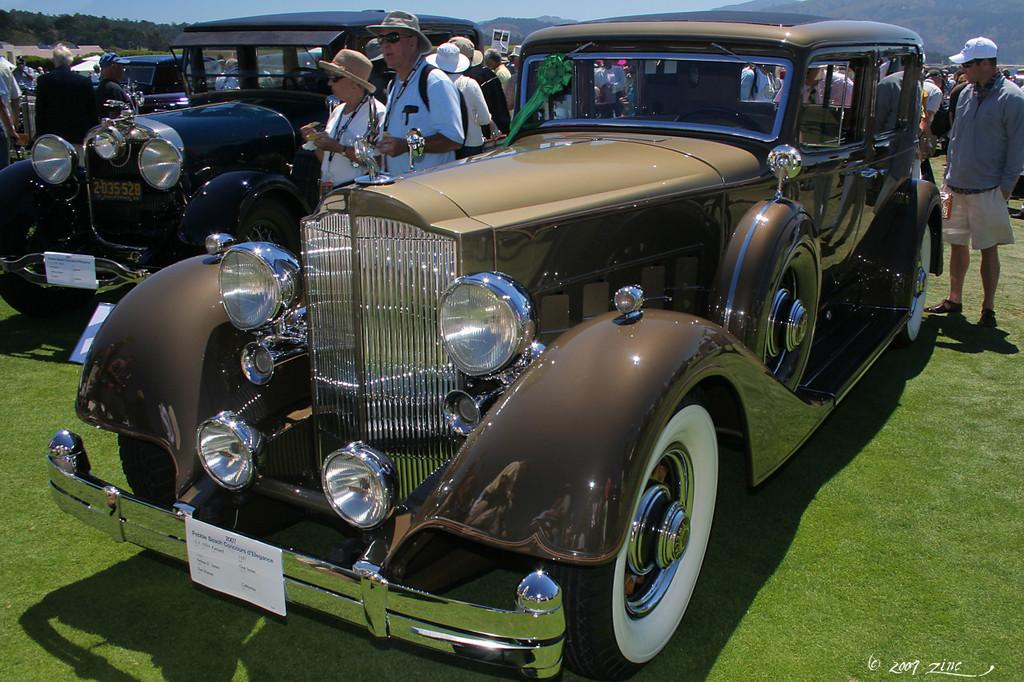What can be seen on the ground in the image? There is a group of cars parked on the ground in the image. What else is visible in the background of the image? There is a group of people wearing hats standing on the ground in the background of the image, as well as mountains and the sky. What type of lamp is hanging from the clouds in the image? There are no clouds or lamps present in the image; it features a group of cars, people wearing hats, mountains, and the sky. 